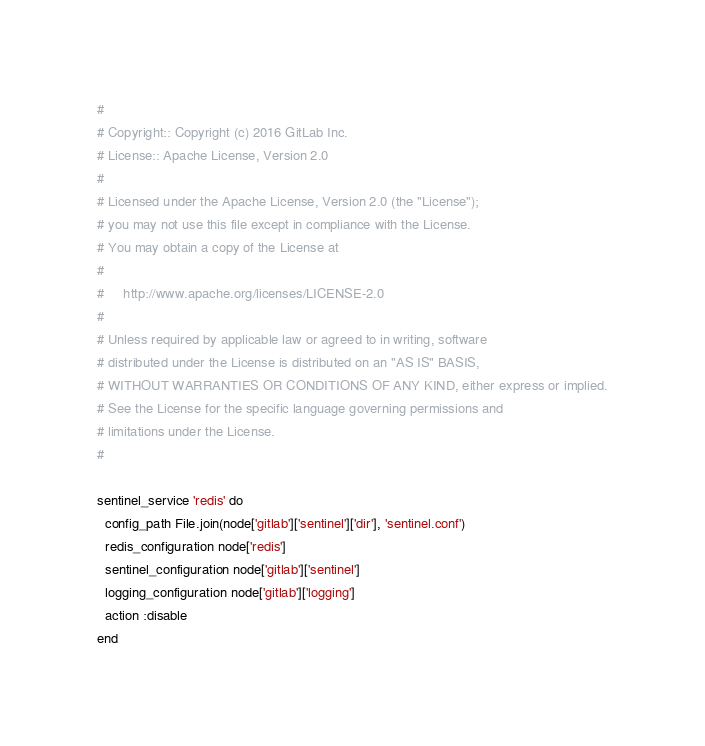<code> <loc_0><loc_0><loc_500><loc_500><_Ruby_>#
# Copyright:: Copyright (c) 2016 GitLab Inc.
# License:: Apache License, Version 2.0
#
# Licensed under the Apache License, Version 2.0 (the "License");
# you may not use this file except in compliance with the License.
# You may obtain a copy of the License at
#
#     http://www.apache.org/licenses/LICENSE-2.0
#
# Unless required by applicable law or agreed to in writing, software
# distributed under the License is distributed on an "AS IS" BASIS,
# WITHOUT WARRANTIES OR CONDITIONS OF ANY KIND, either express or implied.
# See the License for the specific language governing permissions and
# limitations under the License.
#

sentinel_service 'redis' do
  config_path File.join(node['gitlab']['sentinel']['dir'], 'sentinel.conf')
  redis_configuration node['redis']
  sentinel_configuration node['gitlab']['sentinel']
  logging_configuration node['gitlab']['logging']
  action :disable
end
</code> 